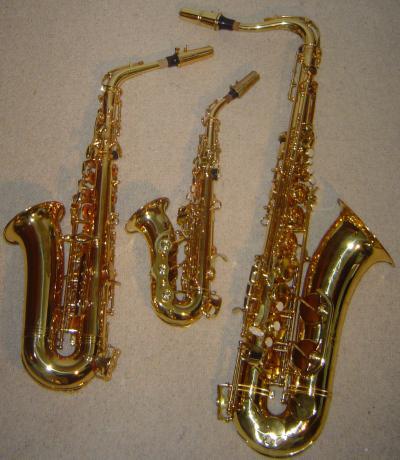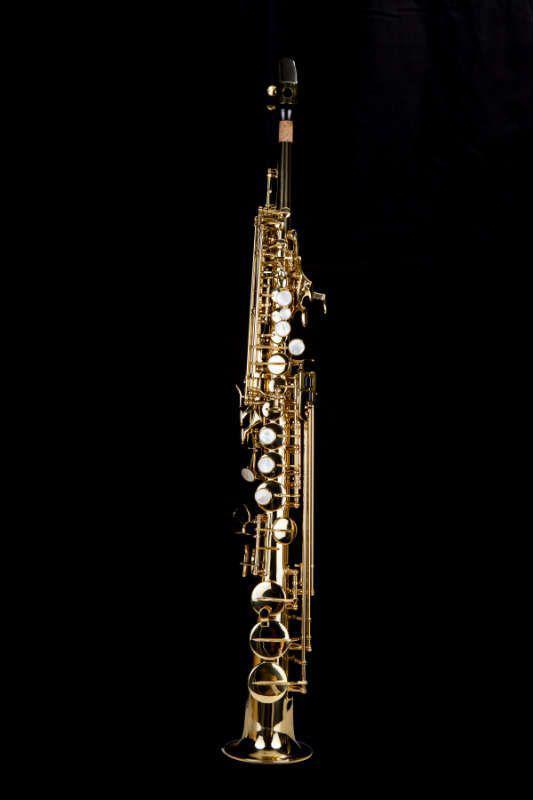The first image is the image on the left, the second image is the image on the right. For the images displayed, is the sentence "Each image shows one saxophone displayed nearly horizontally, with its bell downward, and all saxophones face the same direction." factually correct? Answer yes or no. No. The first image is the image on the left, the second image is the image on the right. Evaluate the accuracy of this statement regarding the images: "Exactly two saxophones the same style, color, and size are positioned at the same angle, horizontal with their bells to the front.". Is it true? Answer yes or no. No. 